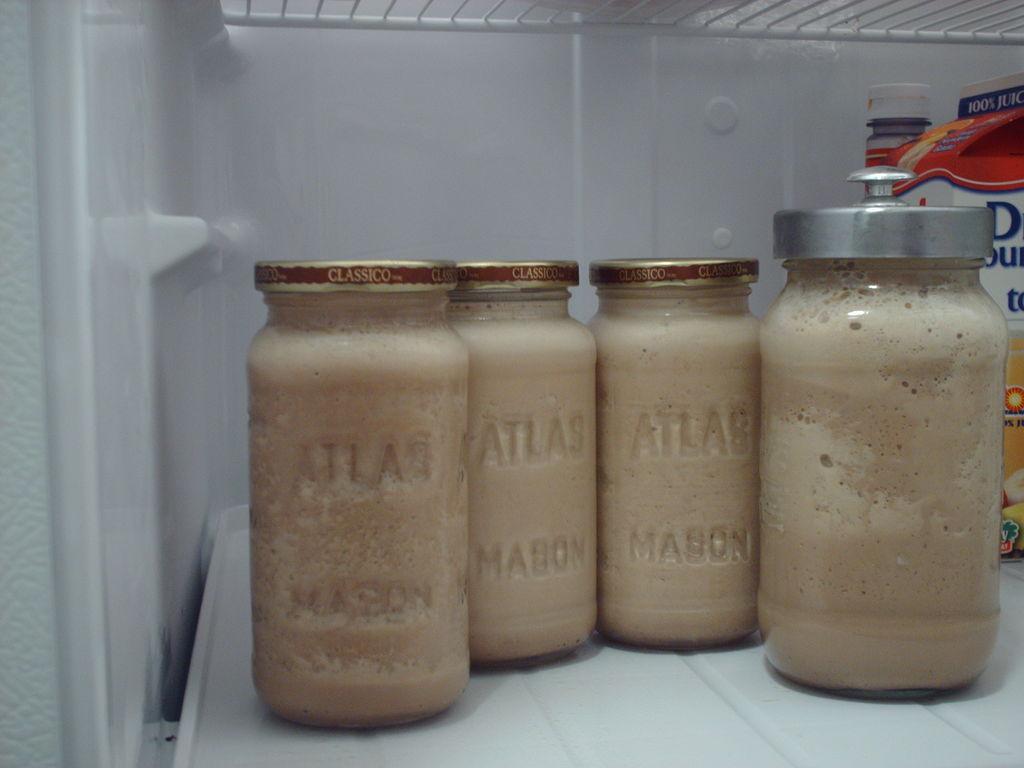In one or two sentences, can you explain what this image depicts? In this image I can see few glass jars and few objects inside the fridge. 